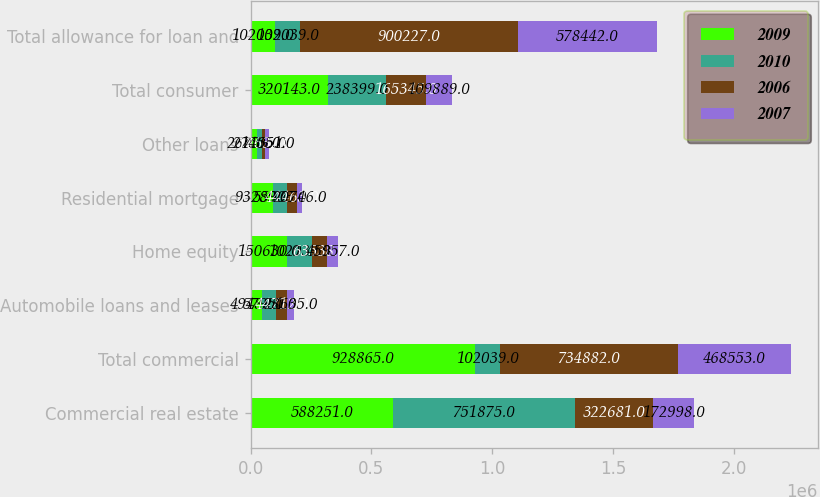Convert chart to OTSL. <chart><loc_0><loc_0><loc_500><loc_500><stacked_bar_chart><ecel><fcel>Commercial real estate<fcel>Total commercial<fcel>Automobile loans and leases<fcel>Home equity<fcel>Residential mortgage<fcel>Other loans<fcel>Total consumer<fcel>Total allowance for loan and<nl><fcel>2009<fcel>588251<fcel>928865<fcel>49488<fcel>150630<fcel>93289<fcel>26736<fcel>320143<fcel>102039<nl><fcel>2010<fcel>751875<fcel>102039<fcel>57951<fcel>102039<fcel>55903<fcel>22506<fcel>238399<fcel>102039<nl><fcel>2006<fcel>322681<fcel>734882<fcel>44712<fcel>63538<fcel>44463<fcel>12632<fcel>165345<fcel>900227<nl><fcel>2007<fcel>172998<fcel>468553<fcel>28635<fcel>45957<fcel>20746<fcel>14551<fcel>109889<fcel>578442<nl></chart> 